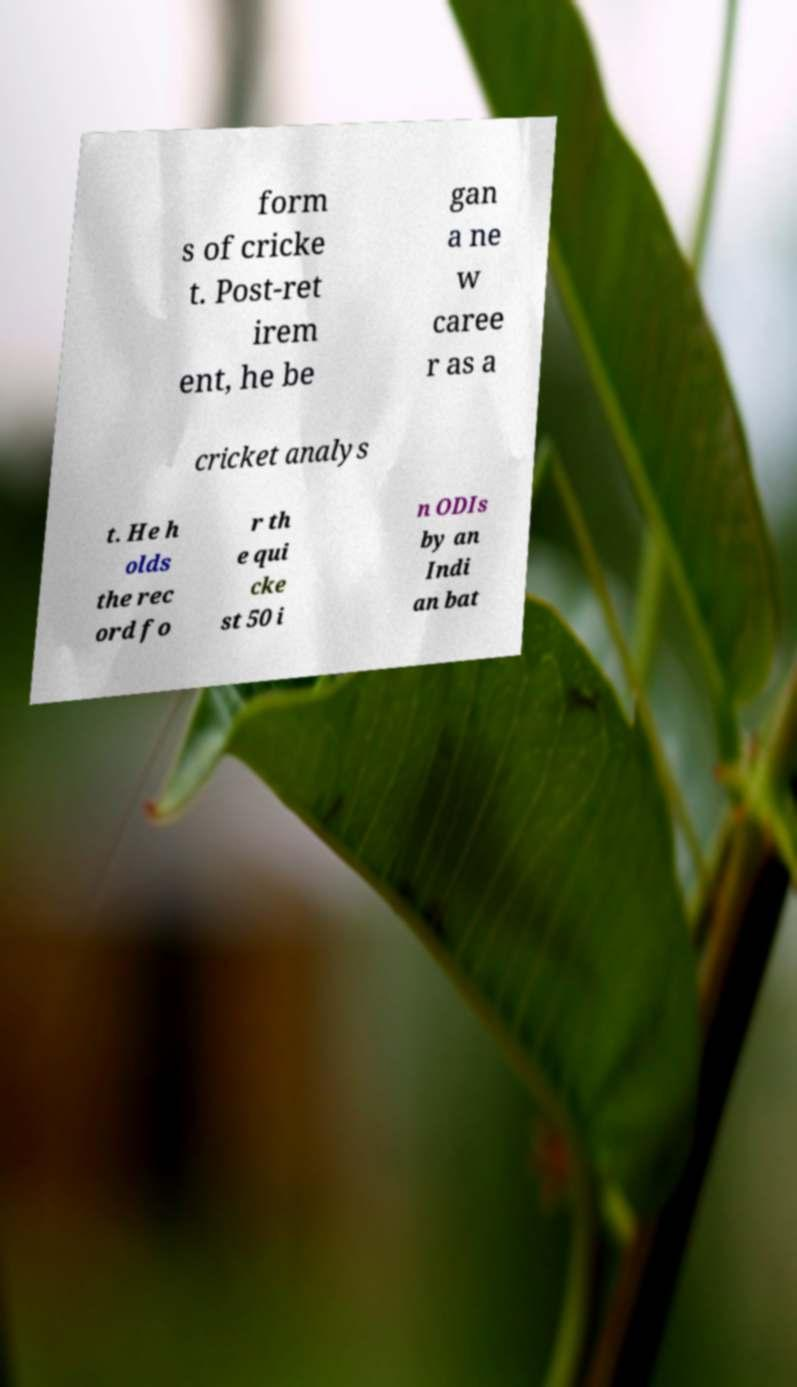Please read and relay the text visible in this image. What does it say? form s of cricke t. Post-ret irem ent, he be gan a ne w caree r as a cricket analys t. He h olds the rec ord fo r th e qui cke st 50 i n ODIs by an Indi an bat 